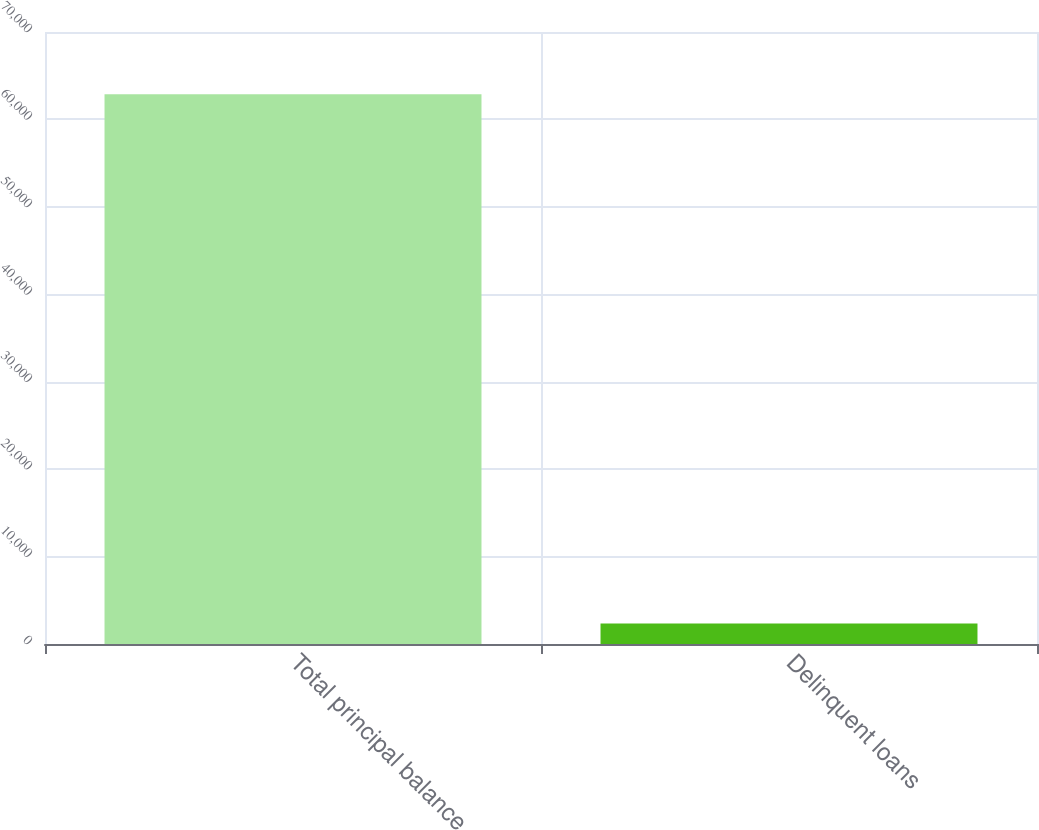Convert chart. <chart><loc_0><loc_0><loc_500><loc_500><bar_chart><fcel>Total principal balance<fcel>Delinquent loans<nl><fcel>62872<fcel>2353<nl></chart> 